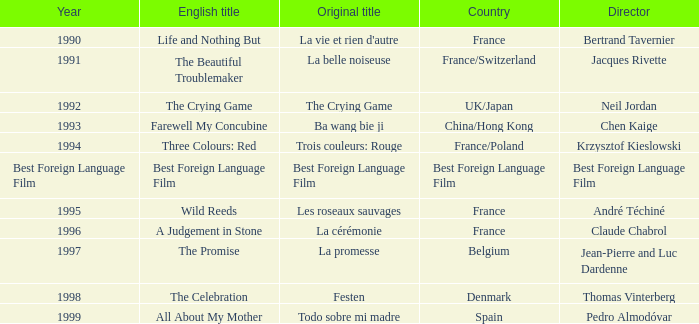What's the primary title of the english title a judgement in stone? La cérémonie. 